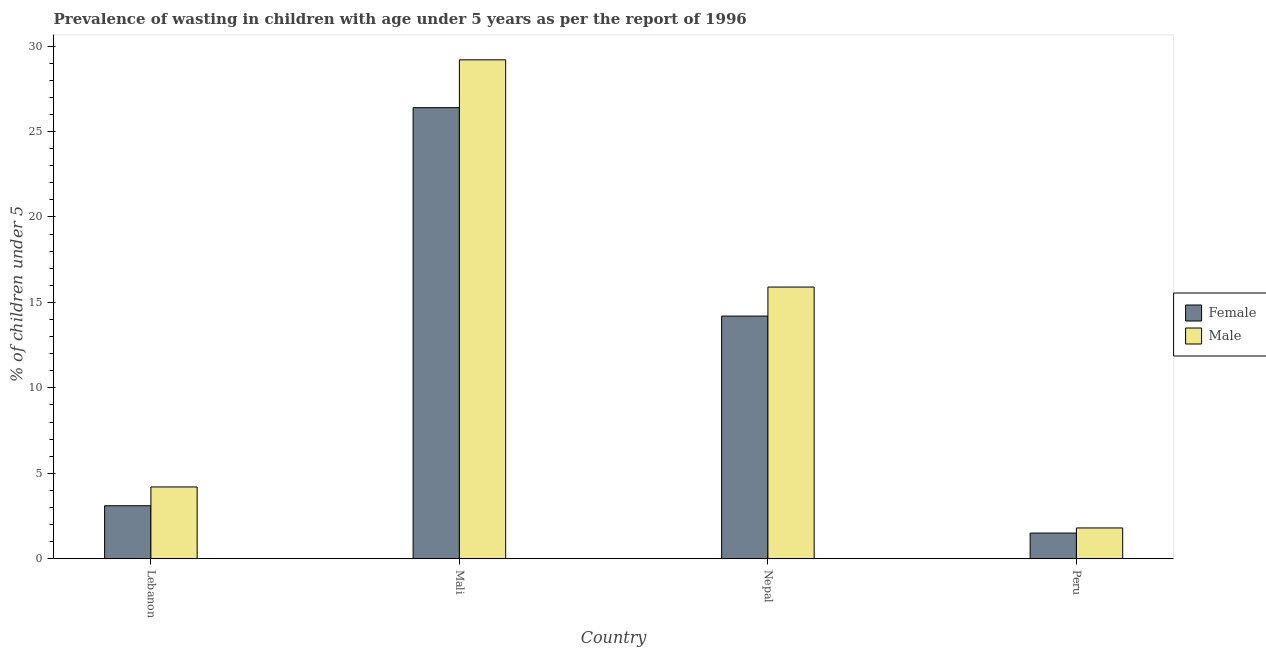How many different coloured bars are there?
Ensure brevity in your answer.  2. How many groups of bars are there?
Ensure brevity in your answer.  4. Are the number of bars on each tick of the X-axis equal?
Give a very brief answer. Yes. What is the label of the 3rd group of bars from the left?
Provide a short and direct response. Nepal. In how many cases, is the number of bars for a given country not equal to the number of legend labels?
Your answer should be compact. 0. What is the percentage of undernourished male children in Lebanon?
Your answer should be compact. 4.2. Across all countries, what is the maximum percentage of undernourished female children?
Ensure brevity in your answer.  26.4. Across all countries, what is the minimum percentage of undernourished female children?
Provide a succinct answer. 1.5. In which country was the percentage of undernourished female children maximum?
Give a very brief answer. Mali. What is the total percentage of undernourished female children in the graph?
Make the answer very short. 45.2. What is the difference between the percentage of undernourished female children in Nepal and that in Peru?
Make the answer very short. 12.7. What is the difference between the percentage of undernourished male children in Peru and the percentage of undernourished female children in Nepal?
Make the answer very short. -12.4. What is the average percentage of undernourished male children per country?
Provide a succinct answer. 12.78. What is the difference between the percentage of undernourished male children and percentage of undernourished female children in Lebanon?
Offer a terse response. 1.1. In how many countries, is the percentage of undernourished male children greater than 27 %?
Give a very brief answer. 1. What is the ratio of the percentage of undernourished female children in Nepal to that in Peru?
Offer a very short reply. 9.47. What is the difference between the highest and the second highest percentage of undernourished female children?
Ensure brevity in your answer.  12.2. What is the difference between the highest and the lowest percentage of undernourished female children?
Your answer should be compact. 24.9. In how many countries, is the percentage of undernourished male children greater than the average percentage of undernourished male children taken over all countries?
Your answer should be very brief. 2. Is the sum of the percentage of undernourished male children in Mali and Peru greater than the maximum percentage of undernourished female children across all countries?
Give a very brief answer. Yes. What does the 2nd bar from the right in Peru represents?
Your answer should be compact. Female. How many countries are there in the graph?
Your answer should be very brief. 4. Does the graph contain grids?
Make the answer very short. No. Where does the legend appear in the graph?
Provide a succinct answer. Center right. How are the legend labels stacked?
Your response must be concise. Vertical. What is the title of the graph?
Ensure brevity in your answer.  Prevalence of wasting in children with age under 5 years as per the report of 1996. What is the label or title of the Y-axis?
Provide a succinct answer.  % of children under 5. What is the  % of children under 5 of Female in Lebanon?
Keep it short and to the point. 3.1. What is the  % of children under 5 of Male in Lebanon?
Ensure brevity in your answer.  4.2. What is the  % of children under 5 of Female in Mali?
Keep it short and to the point. 26.4. What is the  % of children under 5 of Male in Mali?
Your answer should be very brief. 29.2. What is the  % of children under 5 of Female in Nepal?
Provide a succinct answer. 14.2. What is the  % of children under 5 of Male in Nepal?
Keep it short and to the point. 15.9. What is the  % of children under 5 in Male in Peru?
Your response must be concise. 1.8. Across all countries, what is the maximum  % of children under 5 in Female?
Keep it short and to the point. 26.4. Across all countries, what is the maximum  % of children under 5 in Male?
Provide a short and direct response. 29.2. Across all countries, what is the minimum  % of children under 5 in Female?
Keep it short and to the point. 1.5. Across all countries, what is the minimum  % of children under 5 of Male?
Your answer should be very brief. 1.8. What is the total  % of children under 5 of Female in the graph?
Give a very brief answer. 45.2. What is the total  % of children under 5 in Male in the graph?
Your answer should be very brief. 51.1. What is the difference between the  % of children under 5 of Female in Lebanon and that in Mali?
Offer a very short reply. -23.3. What is the difference between the  % of children under 5 of Male in Lebanon and that in Mali?
Provide a short and direct response. -25. What is the difference between the  % of children under 5 of Female in Lebanon and that in Peru?
Offer a terse response. 1.6. What is the difference between the  % of children under 5 in Male in Lebanon and that in Peru?
Provide a short and direct response. 2.4. What is the difference between the  % of children under 5 of Male in Mali and that in Nepal?
Your answer should be compact. 13.3. What is the difference between the  % of children under 5 in Female in Mali and that in Peru?
Give a very brief answer. 24.9. What is the difference between the  % of children under 5 of Male in Mali and that in Peru?
Provide a short and direct response. 27.4. What is the difference between the  % of children under 5 in Female in Nepal and that in Peru?
Offer a very short reply. 12.7. What is the difference between the  % of children under 5 of Female in Lebanon and the  % of children under 5 of Male in Mali?
Provide a short and direct response. -26.1. What is the difference between the  % of children under 5 in Female in Lebanon and the  % of children under 5 in Male in Nepal?
Offer a very short reply. -12.8. What is the difference between the  % of children under 5 in Female in Lebanon and the  % of children under 5 in Male in Peru?
Give a very brief answer. 1.3. What is the difference between the  % of children under 5 in Female in Mali and the  % of children under 5 in Male in Nepal?
Your answer should be very brief. 10.5. What is the difference between the  % of children under 5 in Female in Mali and the  % of children under 5 in Male in Peru?
Provide a succinct answer. 24.6. What is the difference between the  % of children under 5 of Female in Nepal and the  % of children under 5 of Male in Peru?
Keep it short and to the point. 12.4. What is the average  % of children under 5 of Female per country?
Offer a very short reply. 11.3. What is the average  % of children under 5 in Male per country?
Make the answer very short. 12.78. What is the difference between the  % of children under 5 in Female and  % of children under 5 in Male in Lebanon?
Offer a terse response. -1.1. What is the difference between the  % of children under 5 in Female and  % of children under 5 in Male in Mali?
Provide a succinct answer. -2.8. What is the difference between the  % of children under 5 of Female and  % of children under 5 of Male in Nepal?
Offer a terse response. -1.7. What is the ratio of the  % of children under 5 of Female in Lebanon to that in Mali?
Ensure brevity in your answer.  0.12. What is the ratio of the  % of children under 5 in Male in Lebanon to that in Mali?
Offer a very short reply. 0.14. What is the ratio of the  % of children under 5 of Female in Lebanon to that in Nepal?
Your response must be concise. 0.22. What is the ratio of the  % of children under 5 of Male in Lebanon to that in Nepal?
Offer a terse response. 0.26. What is the ratio of the  % of children under 5 of Female in Lebanon to that in Peru?
Provide a short and direct response. 2.07. What is the ratio of the  % of children under 5 in Male in Lebanon to that in Peru?
Provide a succinct answer. 2.33. What is the ratio of the  % of children under 5 in Female in Mali to that in Nepal?
Give a very brief answer. 1.86. What is the ratio of the  % of children under 5 in Male in Mali to that in Nepal?
Offer a very short reply. 1.84. What is the ratio of the  % of children under 5 of Female in Mali to that in Peru?
Make the answer very short. 17.6. What is the ratio of the  % of children under 5 of Male in Mali to that in Peru?
Give a very brief answer. 16.22. What is the ratio of the  % of children under 5 of Female in Nepal to that in Peru?
Give a very brief answer. 9.47. What is the ratio of the  % of children under 5 of Male in Nepal to that in Peru?
Your response must be concise. 8.83. What is the difference between the highest and the lowest  % of children under 5 in Female?
Make the answer very short. 24.9. What is the difference between the highest and the lowest  % of children under 5 in Male?
Provide a succinct answer. 27.4. 